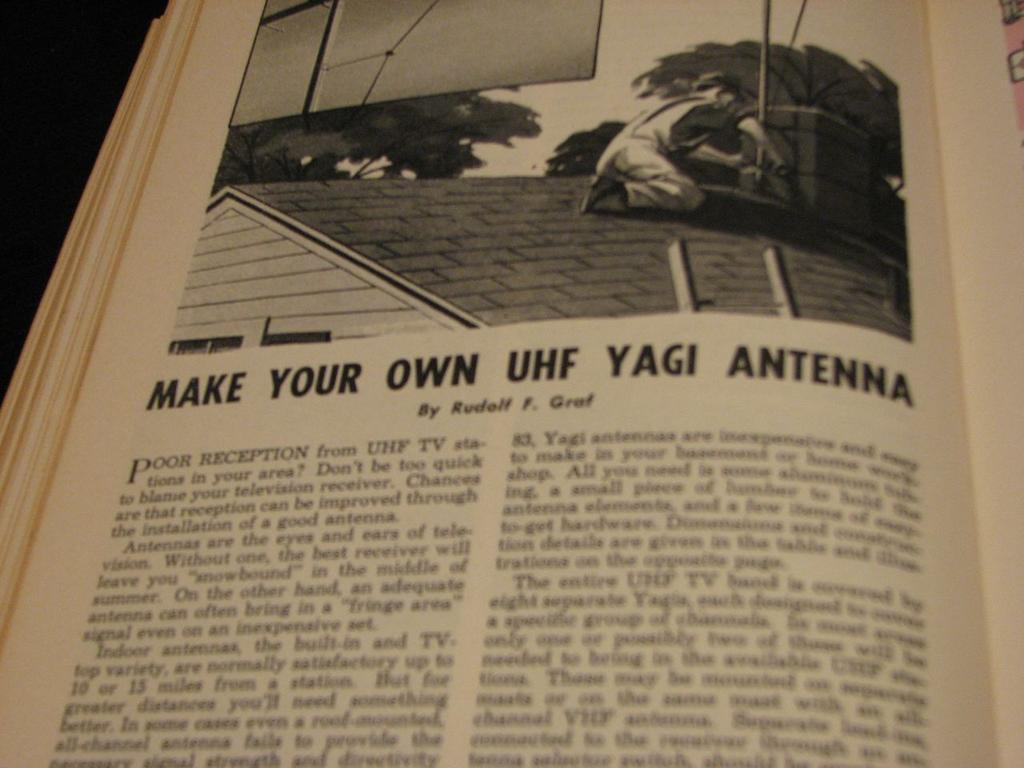Provide a one-sentence caption for the provided image. A page on a book advising people how to make their own UHF yagi antenna. 